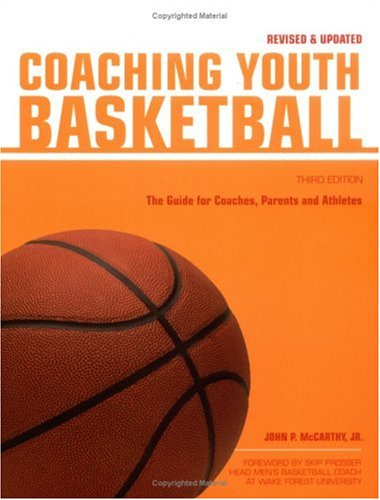Is this a historical book? No, this book is not historical; it is a practical guide aimed at helping coaches and parents in youth basketball. 